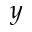<formula> <loc_0><loc_0><loc_500><loc_500>y</formula> 